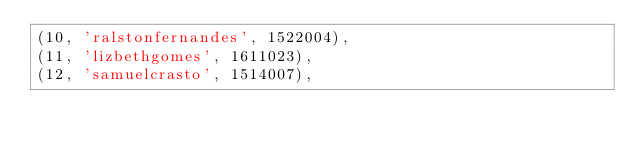Convert code to text. <code><loc_0><loc_0><loc_500><loc_500><_SQL_>(10, 'ralstonfernandes', 1522004),
(11, 'lizbethgomes', 1611023),
(12, 'samuelcrasto', 1514007),</code> 